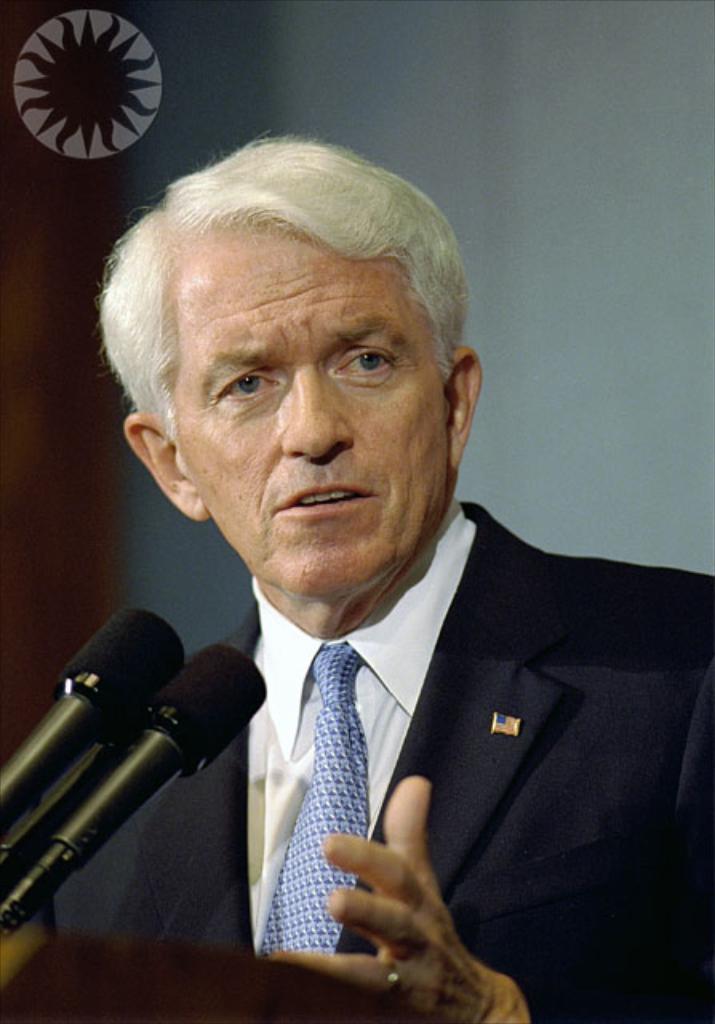In one or two sentences, can you explain what this image depicts? This picture shows a man standing at a podium and speaking. We see couple of microphones and we see a watermark on the top left corner and we see a white background. 